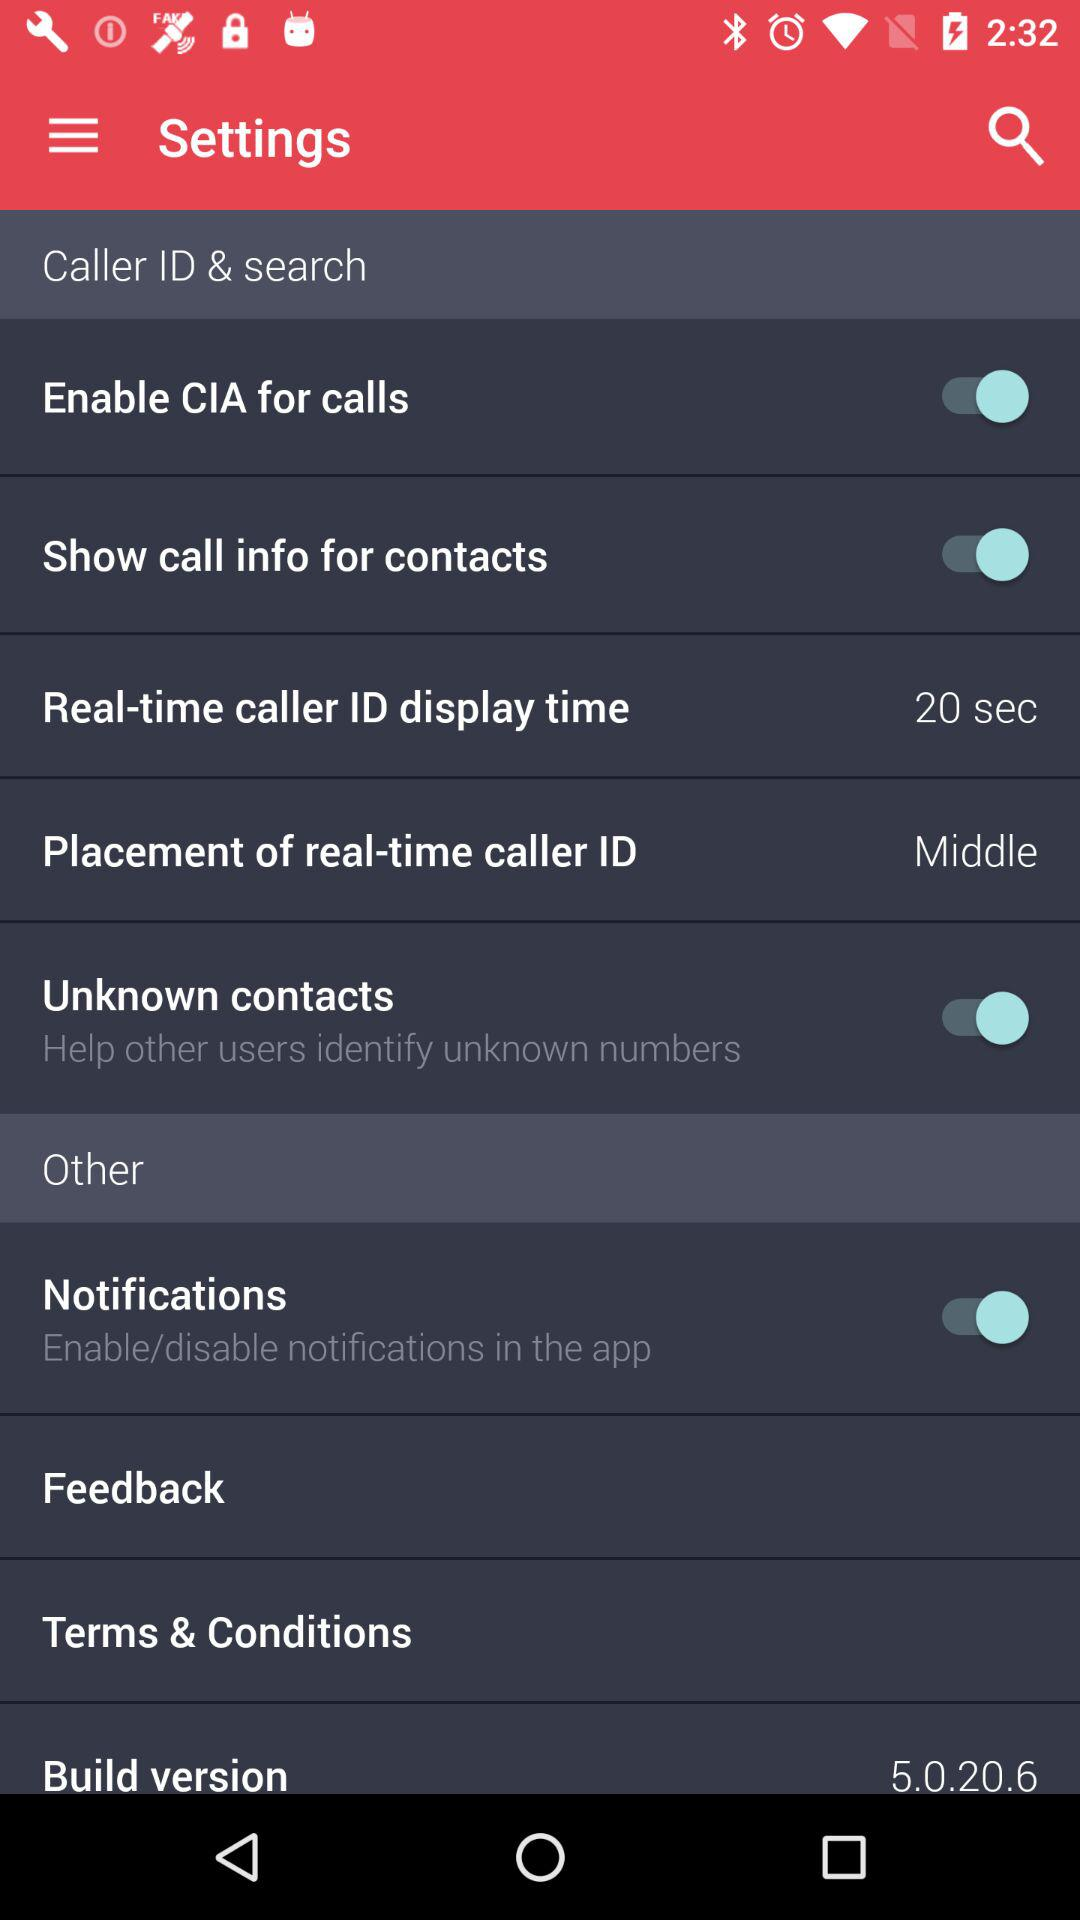What is the status of "Unknown contacts"? The status of "Unknown contacts" is "on". 